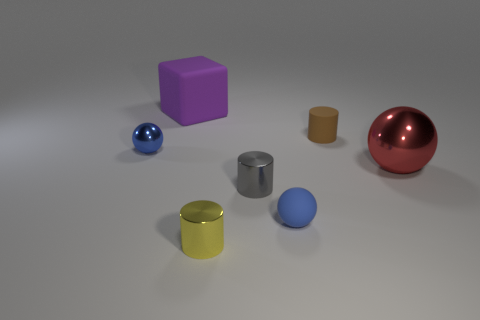What is the gray thing made of?
Offer a very short reply. Metal. There is a cube; is its color the same as the small matte object that is left of the matte cylinder?
Your answer should be compact. No. Are there any other things that are the same size as the yellow cylinder?
Make the answer very short. Yes. There is a matte object that is both behind the large red metallic ball and in front of the big purple rubber thing; what size is it?
Your answer should be compact. Small. There is a large thing that is the same material as the brown cylinder; what shape is it?
Your response must be concise. Cube. Are the large purple object and the blue object that is to the left of the large purple rubber object made of the same material?
Your answer should be compact. No. There is a shiny sphere that is on the right side of the big rubber object; are there any purple objects that are left of it?
Your response must be concise. Yes. There is a small brown thing that is the same shape as the yellow object; what is it made of?
Give a very brief answer. Rubber. What number of small things are on the left side of the small yellow metallic thing that is left of the big metallic ball?
Offer a very short reply. 1. Are there any other things that have the same color as the large rubber block?
Make the answer very short. No. 